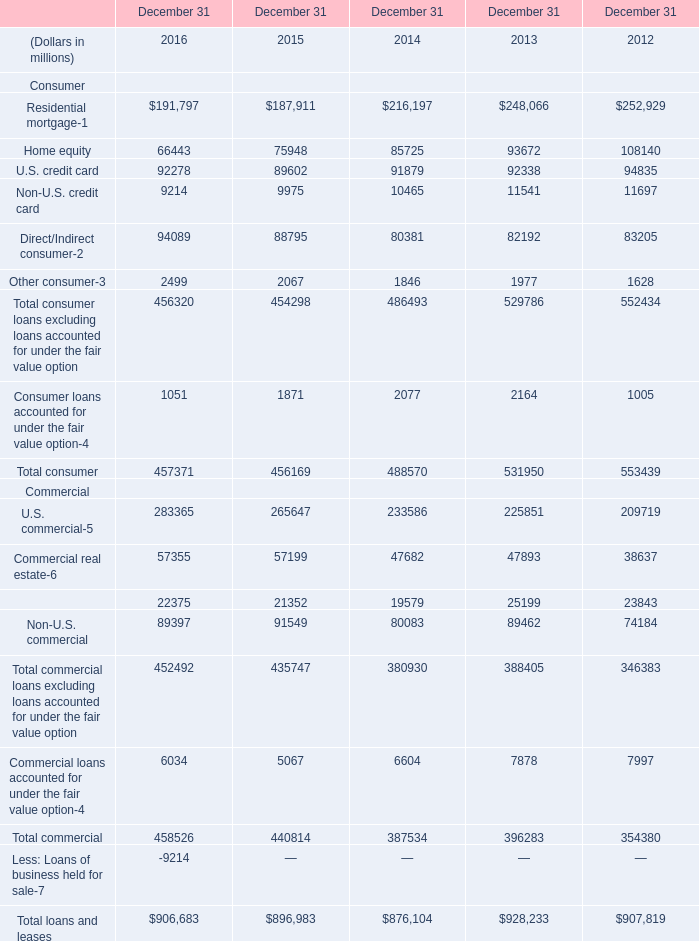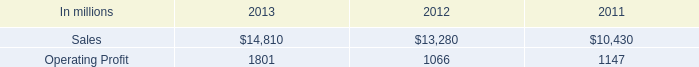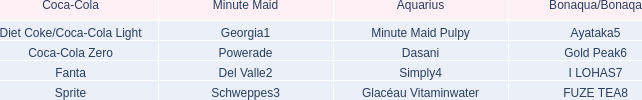What's the sum of Operating Profit of 2013, Home equity of December 31 2013, and Consumer loans accounted for under the fair value option of December 31 2015 ? 
Computations: ((1801.0 + 93672.0) + 1871.0)
Answer: 97344.0. 